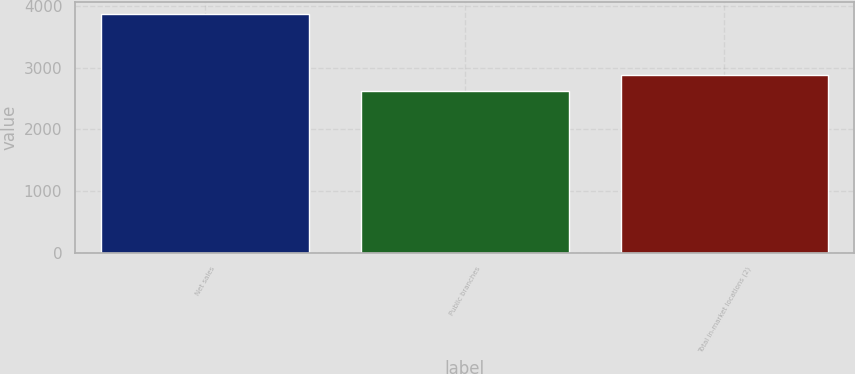Convert chart. <chart><loc_0><loc_0><loc_500><loc_500><bar_chart><fcel>Net sales<fcel>Public branches<fcel>Total in-market locations (2)<nl><fcel>3869.2<fcel>2622<fcel>2886<nl></chart> 